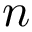<formula> <loc_0><loc_0><loc_500><loc_500>n</formula> 